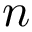<formula> <loc_0><loc_0><loc_500><loc_500>n</formula> 